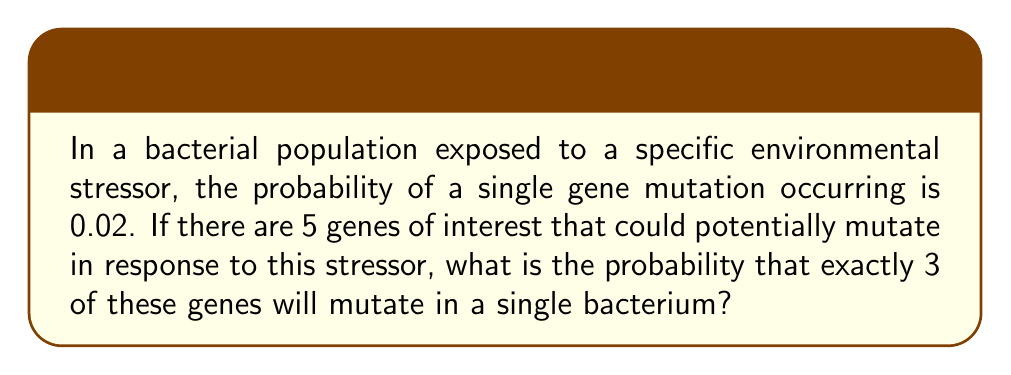Show me your answer to this math problem. To solve this problem, we need to use the binomial probability formula, as we are dealing with a fixed number of independent trials (5 genes) with a constant probability of success (mutation) for each trial.

The binomial probability formula is:

$$P(X = k) = \binom{n}{k} p^k (1-p)^{n-k}$$

Where:
$n$ = number of trials (genes of interest)
$k$ = number of successes (mutations) we're looking for
$p$ = probability of success (mutation) for each trial

Given:
$n = 5$ (5 genes of interest)
$k = 3$ (exactly 3 mutations)
$p = 0.02$ (probability of a single gene mutation)

Step 1: Calculate the binomial coefficient $\binom{n}{k}$
$$\binom{5}{3} = \frac{5!}{3!(5-3)!} = \frac{5 \cdot 4 \cdot 3}{3 \cdot 2 \cdot 1} = 10$$

Step 2: Calculate $p^k$
$$0.02^3 = 0.000008$$

Step 3: Calculate $(1-p)^{n-k}$
$$(1-0.02)^{5-3} = 0.98^2 = 0.9604$$

Step 4: Multiply the results from steps 1, 2, and 3
$$10 \cdot 0.000008 \cdot 0.9604 = 0.00007683$$

Therefore, the probability of exactly 3 out of 5 genes mutating is approximately 0.00007683 or 0.007683%.
Answer: $7.683 \times 10^{-5}$ 